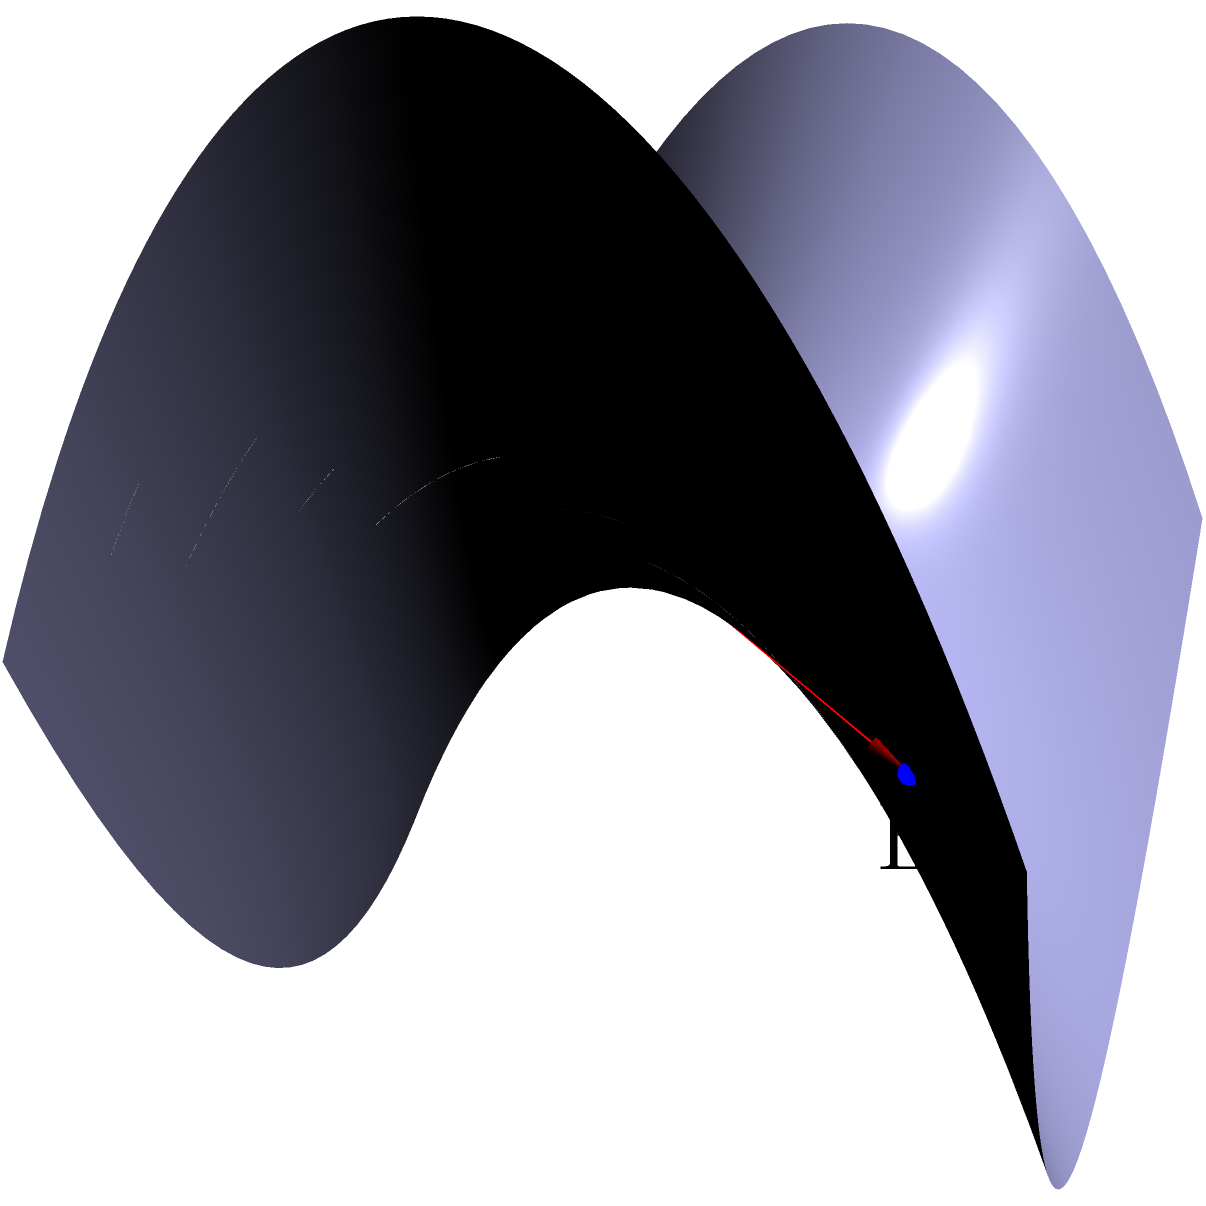On a saddle-shaped surface described by the equation $z = x^2 - y^2$, consider two points A(-1.5, -1.5, 0.5) and B(1.5, 1.5, 0.5). Which of the following statements best describes the geodesic (shortest path) between these two points?

a) The geodesic is a straight line segment connecting A and B.
b) The geodesic follows the curvature of the saddle, deviating from a straight line.
c) The geodesic is a circular arc on the surface.
d) There are multiple geodesics of equal length between A and B. Let's approach this step-by-step:

1) In Euclidean geometry, the shortest path between two points is always a straight line. However, on curved surfaces (non-Euclidean geometry), this is not necessarily true.

2) The surface described by $z = x^2 - y^2$ is a hyperbolic paraboloid, commonly known as a saddle surface due to its shape.

3) On a saddle surface, the curvature changes sign. It's positive in one direction and negative in the perpendicular direction.

4) The geodesic (shortest path) on such a surface is influenced by this changing curvature. It tends to "bend" to minimize the total distance traveled on the curved surface.

5) A straight line segment between A and B would not lie entirely on the surface, except for special cases (like points on the same generatrix).

6) The actual geodesic would follow a path that balances between the positive and negative curvature regions of the saddle.

7) This path is unique (barring symmetrical cases) and is neither a straight line nor a simple curve like a circular arc.

8) The geodesic equation for this surface is complex and requires solving differential equations, but qualitatively, we can say it will deviate from the straight line path.

Therefore, the correct answer is (b). The geodesic follows the curvature of the saddle, deviating from a straight line.
Answer: b) The geodesic follows the curvature of the saddle, deviating from a straight line. 